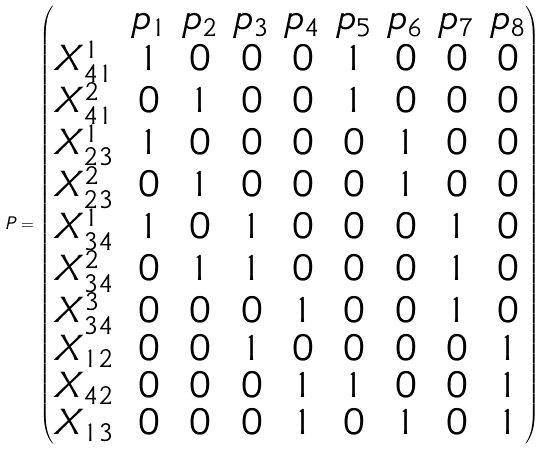Convert formula to latex. <formula><loc_0><loc_0><loc_500><loc_500>P = \begin{pmatrix} & p _ { 1 } & p _ { 2 } & p _ { 3 } & p _ { 4 } & p _ { 5 } & p _ { 6 } & p _ { 7 } & p _ { 8 } \\ X _ { 4 1 } ^ { 1 } & 1 & 0 & 0 & 0 & 1 & 0 & 0 & 0 \\ X _ { 4 1 } ^ { 2 } & 0 & 1 & 0 & 0 & 1 & 0 & 0 & 0 \\ X _ { 2 3 } ^ { 1 } & 1 & 0 & 0 & 0 & 0 & 1 & 0 & 0 \\ X _ { 2 3 } ^ { 2 } & 0 & 1 & 0 & 0 & 0 & 1 & 0 & 0 \\ X _ { 3 4 } ^ { 1 } & 1 & 0 & 1 & 0 & 0 & 0 & 1 & 0 \\ X _ { 3 4 } ^ { 2 } & 0 & 1 & 1 & 0 & 0 & 0 & 1 & 0 \\ X _ { 3 4 } ^ { 3 } & 0 & 0 & 0 & 1 & 0 & 0 & 1 & 0 \\ X _ { 1 2 } & 0 & 0 & 1 & 0 & 0 & 0 & 0 & 1 \\ X _ { 4 2 } & 0 & 0 & 0 & 1 & 1 & 0 & 0 & 1 \\ X _ { 1 3 } & 0 & 0 & 0 & 1 & 0 & 1 & 0 & 1 \end{pmatrix}</formula> 